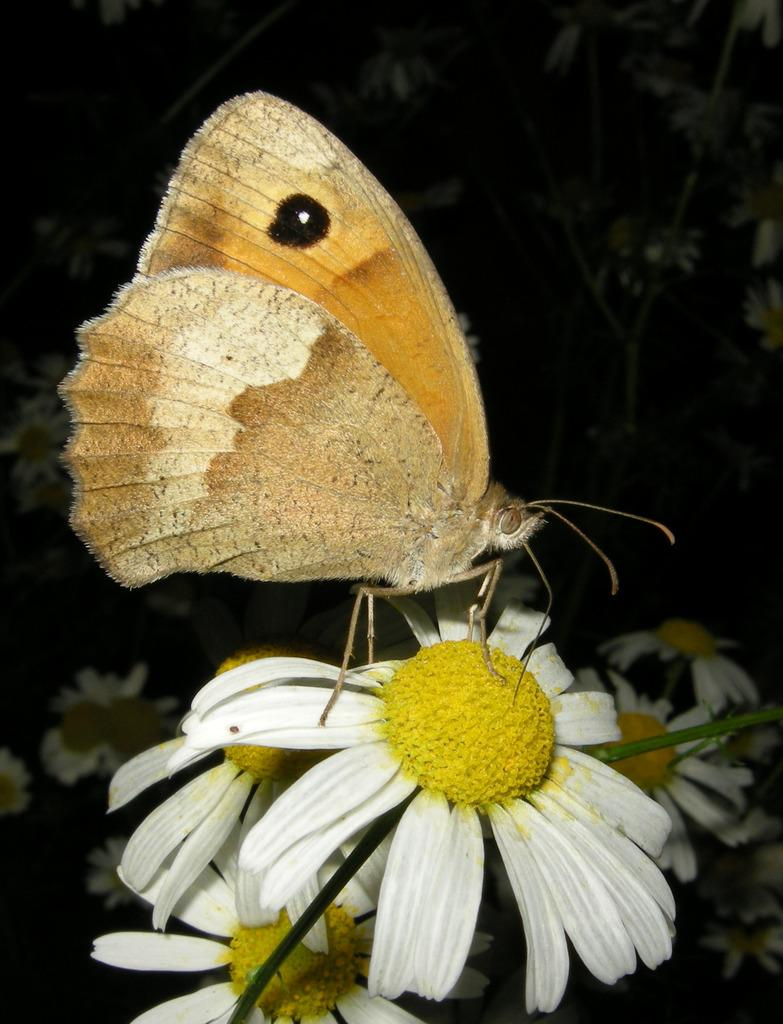What is the main subject of the image? There is a butterfly in the image. What is the butterfly resting on? The butterfly is on a white flower. How would you describe the overall color scheme of the image? The background of the image is dark. What other natural elements can be seen in the image? There are additional flowers and plants visible in the background. Can you see a donkey swimming in the ocean in the image? No, there is no donkey or ocean present in the image. The image features a butterfly on a white flower with a dark background and additional flowers and plants in the background. 